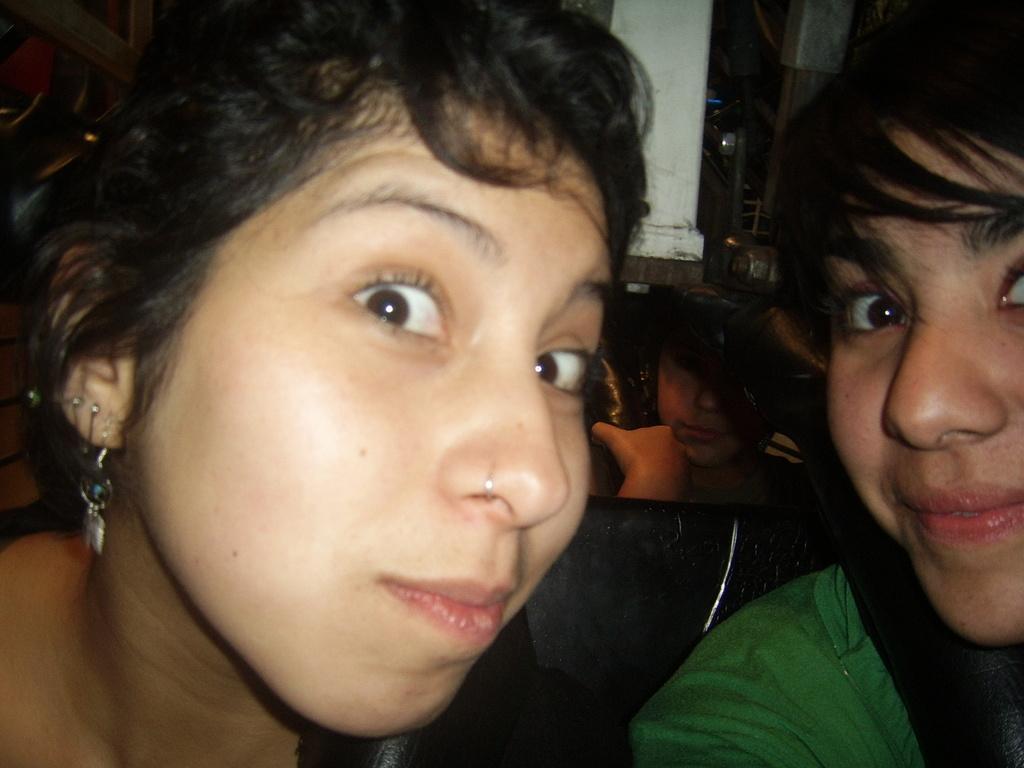Please provide a concise description of this image. In this image, we can see people and in the background, there is a wall and we can see some objects. 